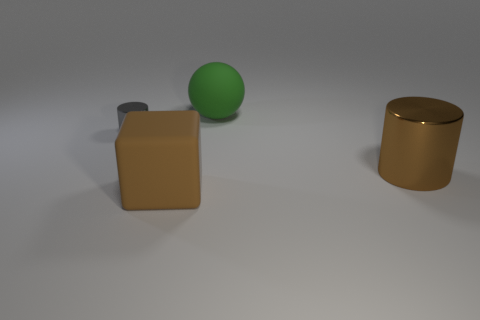Subtract all brown balls. Subtract all purple blocks. How many balls are left? 1 Add 3 brown matte blocks. How many objects exist? 7 Subtract all blocks. How many objects are left? 3 Add 4 big brown cubes. How many big brown cubes are left? 5 Add 4 red blocks. How many red blocks exist? 4 Subtract 0 blue blocks. How many objects are left? 4 Subtract all small objects. Subtract all metallic cylinders. How many objects are left? 1 